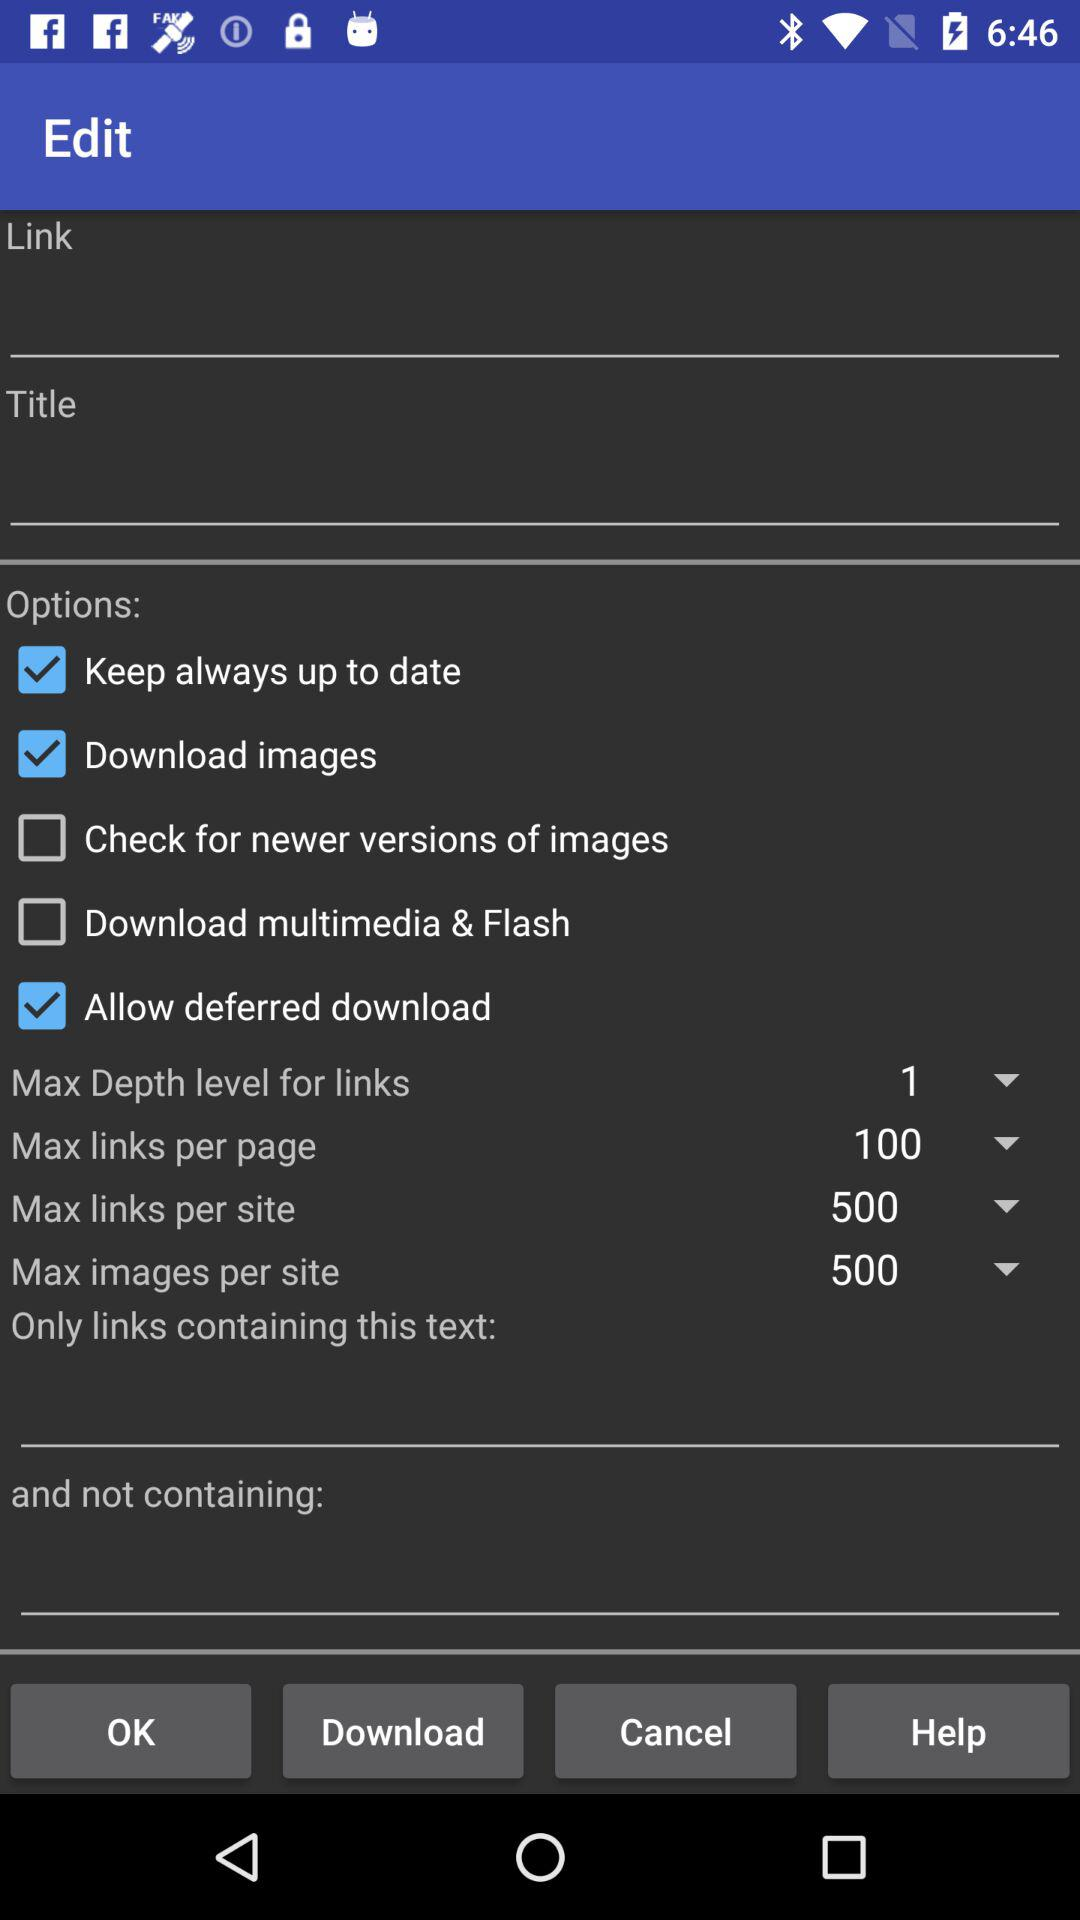What is the set value for "Max Depth level for links"? The set value for "Max Depth level for links" is 1. 